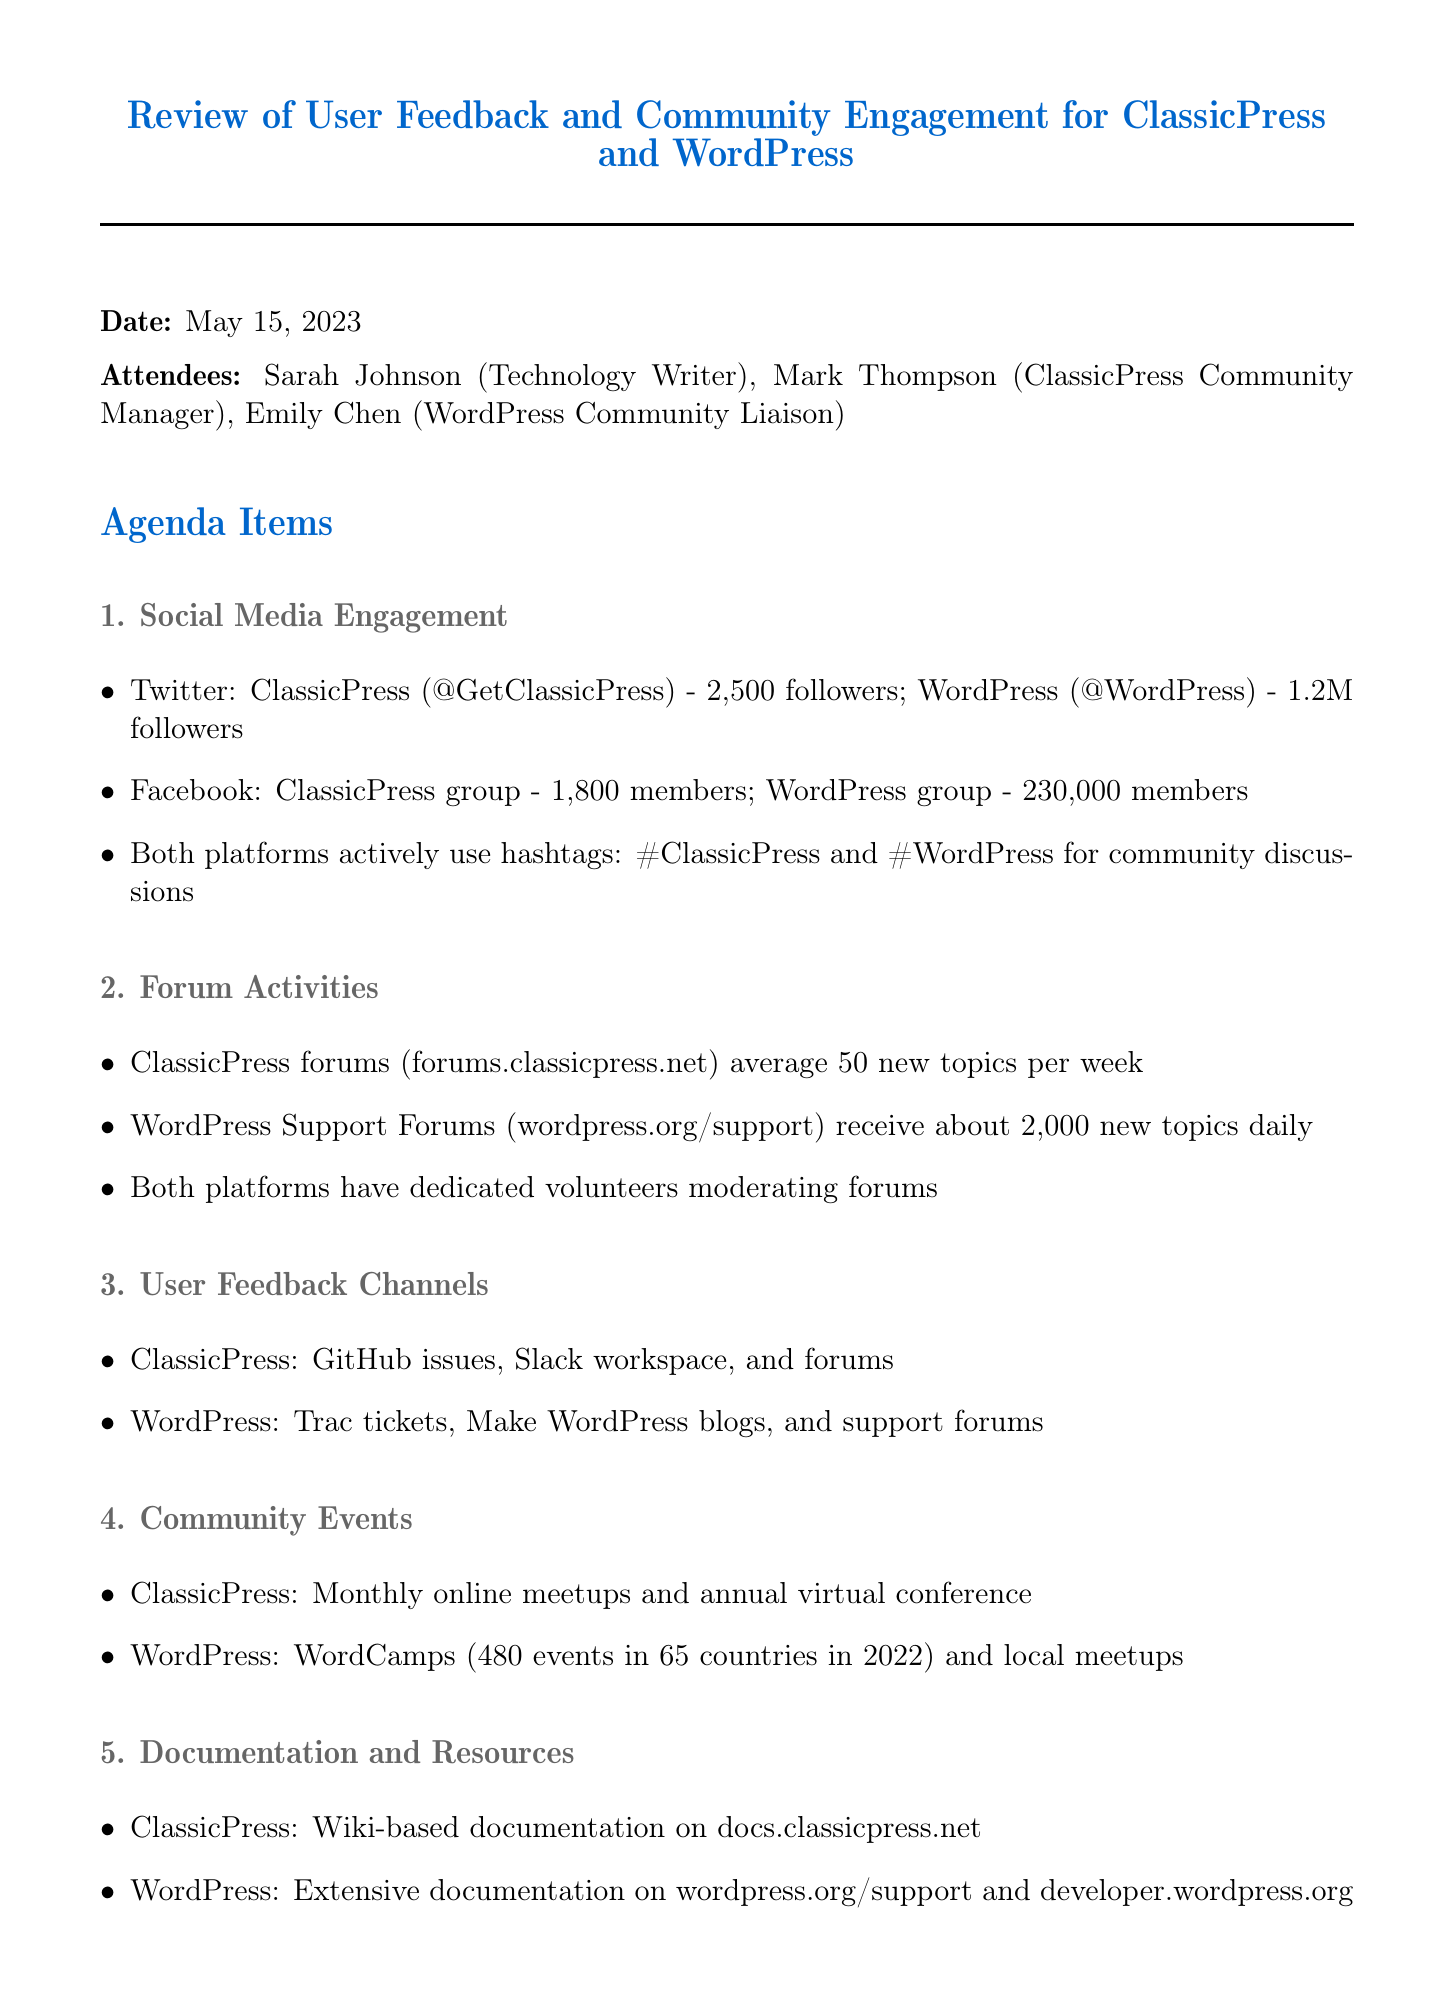what is the date of the meeting? The date of the meeting is mentioned in the document as May 15, 2023.
Answer: May 15, 2023 how many followers does ClassicPress have on Twitter? The document states that ClassicPress has 2,500 followers on Twitter.
Answer: 2,500 what is the average number of new topics per week in ClassicPress forums? The document indicates that ClassicPress forums average 50 new topics per week.
Answer: 50 how many WordCamps were held in 2022? The document details that there were 480 WordCamps in 2022.
Answer: 480 which platforms have dedicated volunteers moderating forums? The document mentions that both ClassicPress and WordPress have dedicated volunteers moderating forums.
Answer: Both what are the user feedback channels for WordPress? The document lists Trac tickets, Make WordPress blogs, and support forums as user feedback channels for WordPress.
Answer: Trac tickets, Make WordPress blogs, and support forums what is one action item mentioned in the meeting? The document highlights several action items, one of which is analyzing engagement rates on social media platforms.
Answer: Analyze engagement rates on social media platforms what type of documentation does ClassicPress have? The document specifies that ClassicPress has Wiki-based documentation on docs.classicpress.net.
Answer: Wiki-based documentation how many members does the WordPress Facebook group have? The document states that the WordPress Facebook group has 230,000 members.
Answer: 230,000 